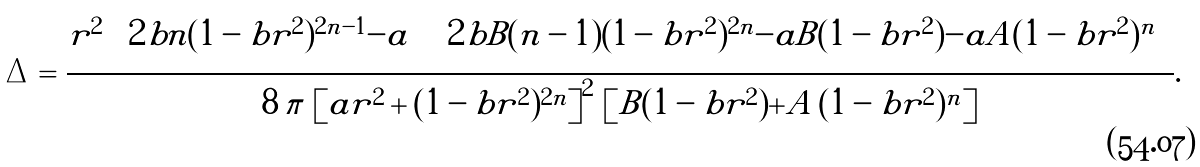<formula> <loc_0><loc_0><loc_500><loc_500>\Delta = \frac { r ^ { 2 } \, \left [ 2 b n ( 1 - b r ^ { 2 } ) ^ { 2 n - 1 } - a \right ] \left [ 2 b B ( n - 1 ) ( 1 - b r ^ { 2 } ) ^ { 2 n } - a B ( 1 - b r ^ { 2 } ) - a A ( 1 - b r ^ { 2 } ) ^ { n } \right ] } { 8 \, \pi \, \left [ a r ^ { 2 } + ( 1 - b r ^ { 2 } ) ^ { 2 n } \right ] ^ { 2 } \, \left [ B ( 1 - b r ^ { 2 } ) + A \, ( 1 - b r ^ { 2 } ) ^ { n } \right ] } .</formula> 